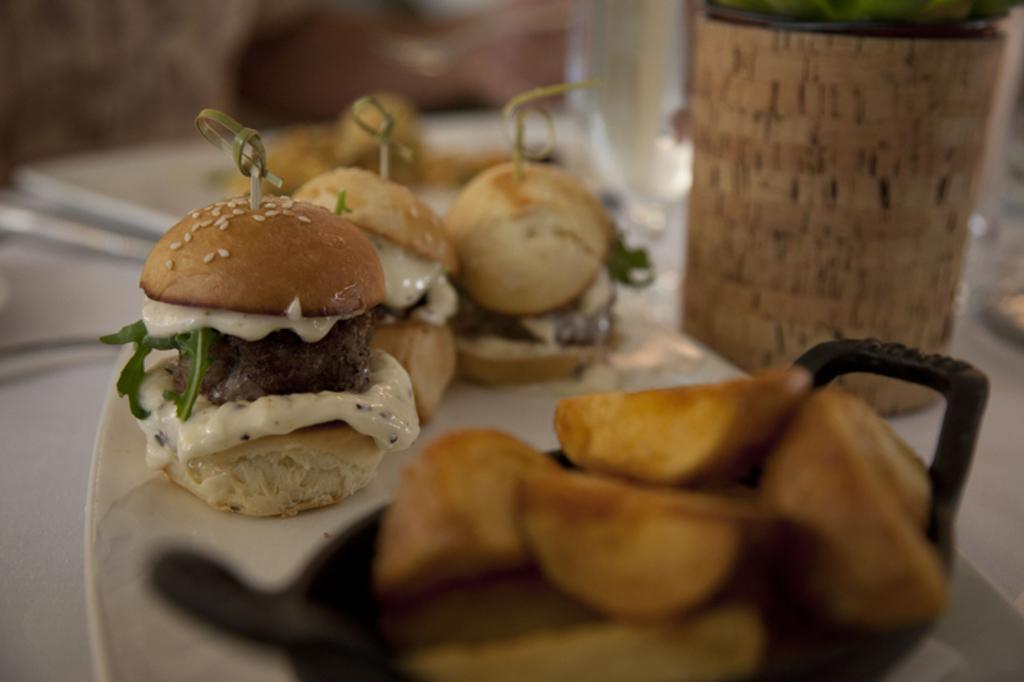What is on the plate in the image? There is food in a plate in the image. What else can be seen on the table in the image? There are other things on the table in the image, but the specific items are not mentioned in the provided facts. Is there a tiger in the image? No, there is no tiger present in the image. What color is the paint on the wall in the image? There is no mention of paint or a wall in the provided facts, so it cannot be determined from the image. 